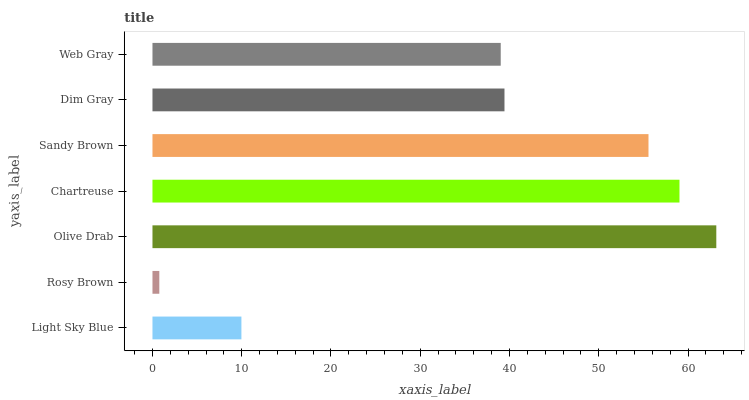Is Rosy Brown the minimum?
Answer yes or no. Yes. Is Olive Drab the maximum?
Answer yes or no. Yes. Is Olive Drab the minimum?
Answer yes or no. No. Is Rosy Brown the maximum?
Answer yes or no. No. Is Olive Drab greater than Rosy Brown?
Answer yes or no. Yes. Is Rosy Brown less than Olive Drab?
Answer yes or no. Yes. Is Rosy Brown greater than Olive Drab?
Answer yes or no. No. Is Olive Drab less than Rosy Brown?
Answer yes or no. No. Is Dim Gray the high median?
Answer yes or no. Yes. Is Dim Gray the low median?
Answer yes or no. Yes. Is Olive Drab the high median?
Answer yes or no. No. Is Light Sky Blue the low median?
Answer yes or no. No. 